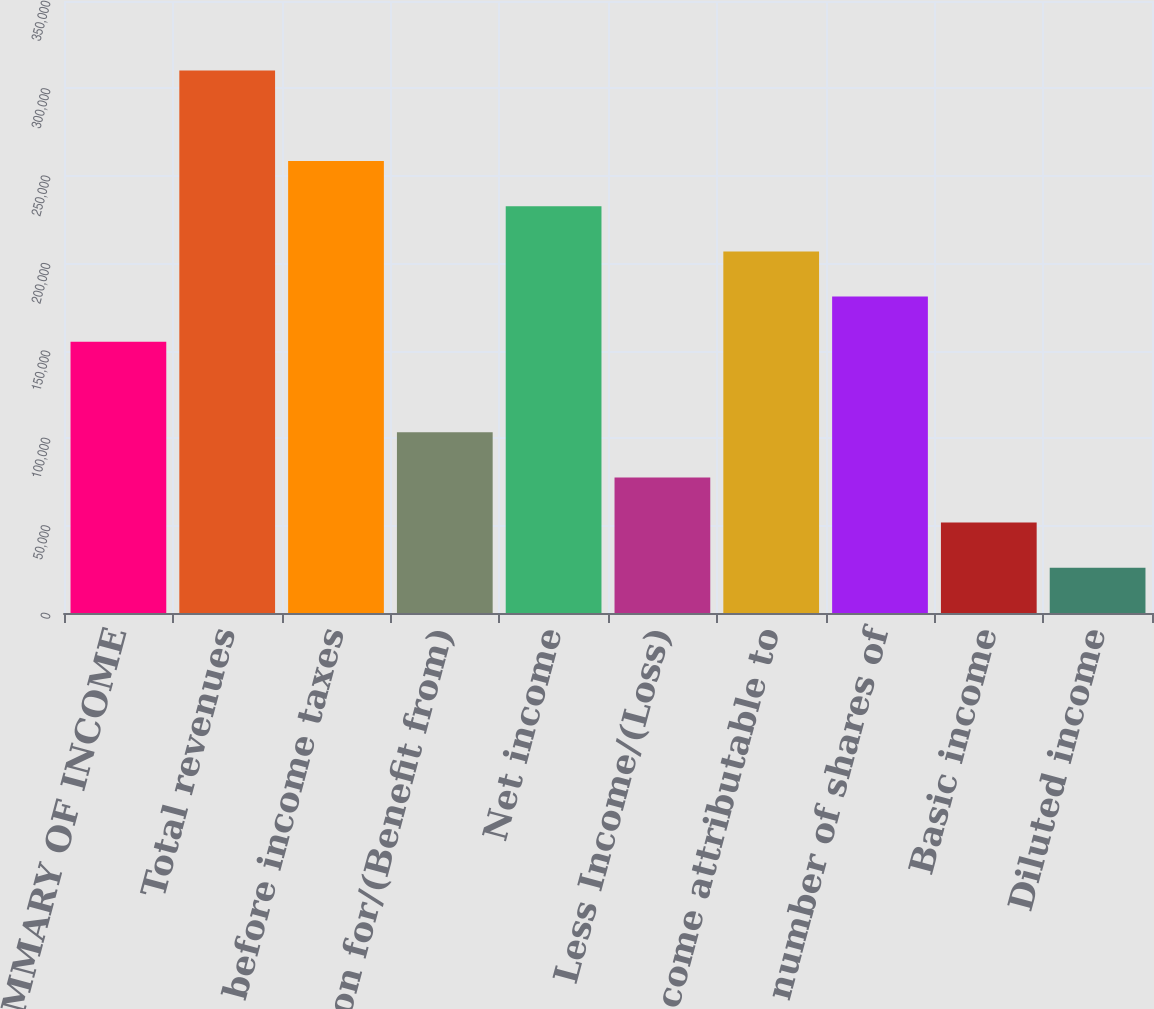Convert chart. <chart><loc_0><loc_0><loc_500><loc_500><bar_chart><fcel>SUMMARY OF INCOME<fcel>Total revenues<fcel>Income before income taxes<fcel>Provision for/(Benefit from)<fcel>Net income<fcel>Less Income/(Loss)<fcel>Net income attributable to<fcel>Average number of shares of<fcel>Basic income<fcel>Diluted income<nl><fcel>155098<fcel>310195<fcel>258496<fcel>103399<fcel>232646<fcel>77549.3<fcel>206797<fcel>180947<fcel>51699.7<fcel>25850.2<nl></chart> 